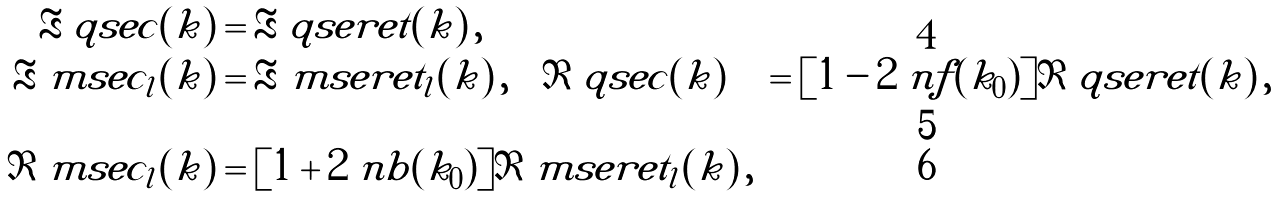Convert formula to latex. <formula><loc_0><loc_0><loc_500><loc_500>\Re \ q s e c ( k ) & = \Re \ q s e r e t ( k ) \, , \\ \Re \ m s e c _ { l } ( k ) & = \Re \ m s e r e t _ { l } ( k ) \, , \quad \Im \ q s e c ( k ) & = [ 1 - 2 \ n f ( k _ { 0 } ) ] \Im \ q s e r e t ( k ) \, , \\ \Im \ m s e c _ { l } ( k ) & = [ 1 + 2 \ n b ( k _ { 0 } ) ] \Im \ m s e r e t _ { l } ( k ) \, ,</formula> 